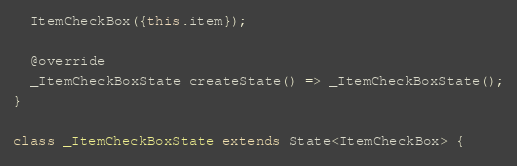<code> <loc_0><loc_0><loc_500><loc_500><_Dart_>  ItemCheckBox({this.item});

  @override
  _ItemCheckBoxState createState() => _ItemCheckBoxState();
}

class _ItemCheckBoxState extends State<ItemCheckBox> {
</code> 